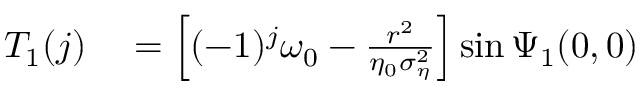Convert formula to latex. <formula><loc_0><loc_0><loc_500><loc_500>\begin{array} { r l } { T _ { 1 } ( j ) } & = \left [ ( - 1 ) ^ { j } \omega _ { 0 } - \frac { r ^ { 2 } } { \eta _ { 0 } \sigma _ { \eta } ^ { 2 } } \right ] \sin \Psi _ { 1 } ( 0 , 0 ) } \end{array}</formula> 